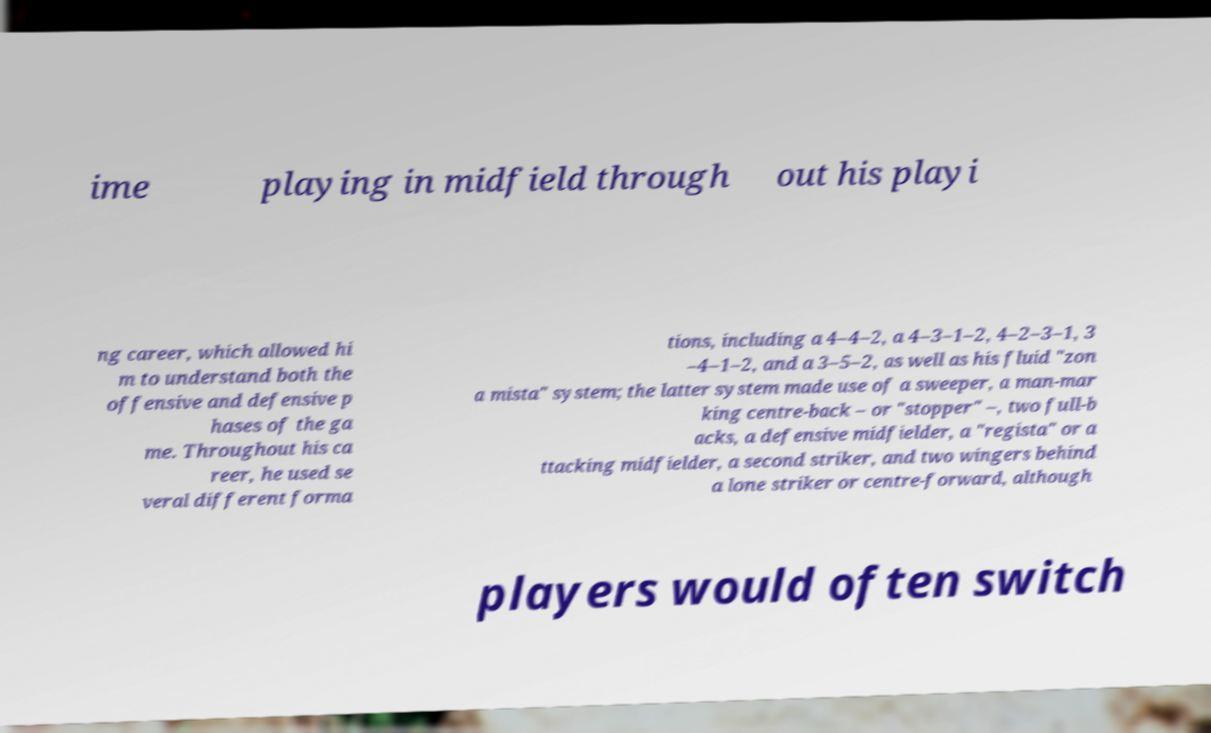There's text embedded in this image that I need extracted. Can you transcribe it verbatim? ime playing in midfield through out his playi ng career, which allowed hi m to understand both the offensive and defensive p hases of the ga me. Throughout his ca reer, he used se veral different forma tions, including a 4–4–2, a 4–3–1–2, 4–2–3–1, 3 –4–1–2, and a 3–5–2, as well as his fluid "zon a mista" system; the latter system made use of a sweeper, a man-mar king centre-back – or "stopper" –, two full-b acks, a defensive midfielder, a "regista" or a ttacking midfielder, a second striker, and two wingers behind a lone striker or centre-forward, although players would often switch 